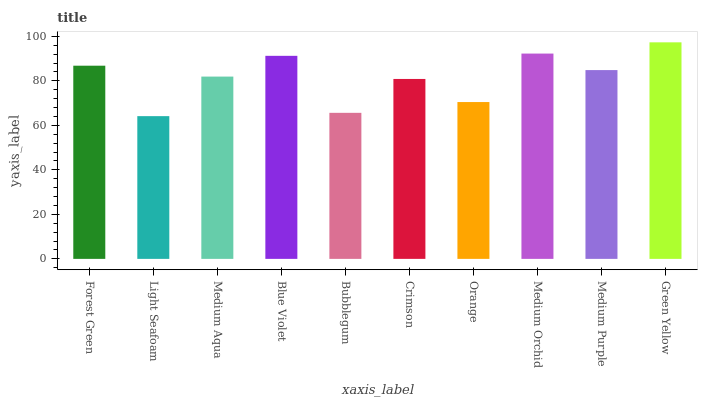Is Light Seafoam the minimum?
Answer yes or no. Yes. Is Green Yellow the maximum?
Answer yes or no. Yes. Is Medium Aqua the minimum?
Answer yes or no. No. Is Medium Aqua the maximum?
Answer yes or no. No. Is Medium Aqua greater than Light Seafoam?
Answer yes or no. Yes. Is Light Seafoam less than Medium Aqua?
Answer yes or no. Yes. Is Light Seafoam greater than Medium Aqua?
Answer yes or no. No. Is Medium Aqua less than Light Seafoam?
Answer yes or no. No. Is Medium Purple the high median?
Answer yes or no. Yes. Is Medium Aqua the low median?
Answer yes or no. Yes. Is Blue Violet the high median?
Answer yes or no. No. Is Light Seafoam the low median?
Answer yes or no. No. 